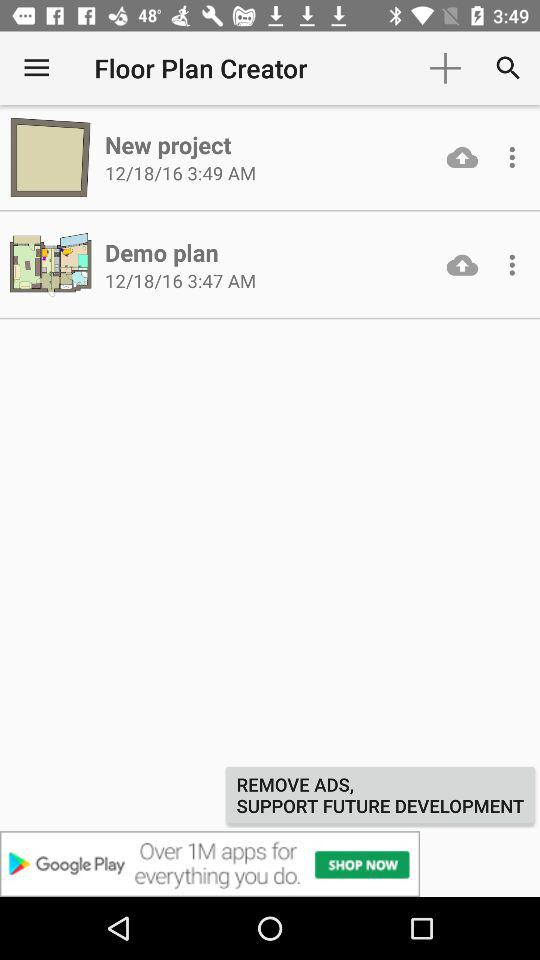What is the application name? The application name is "Floor Plan Creator". 